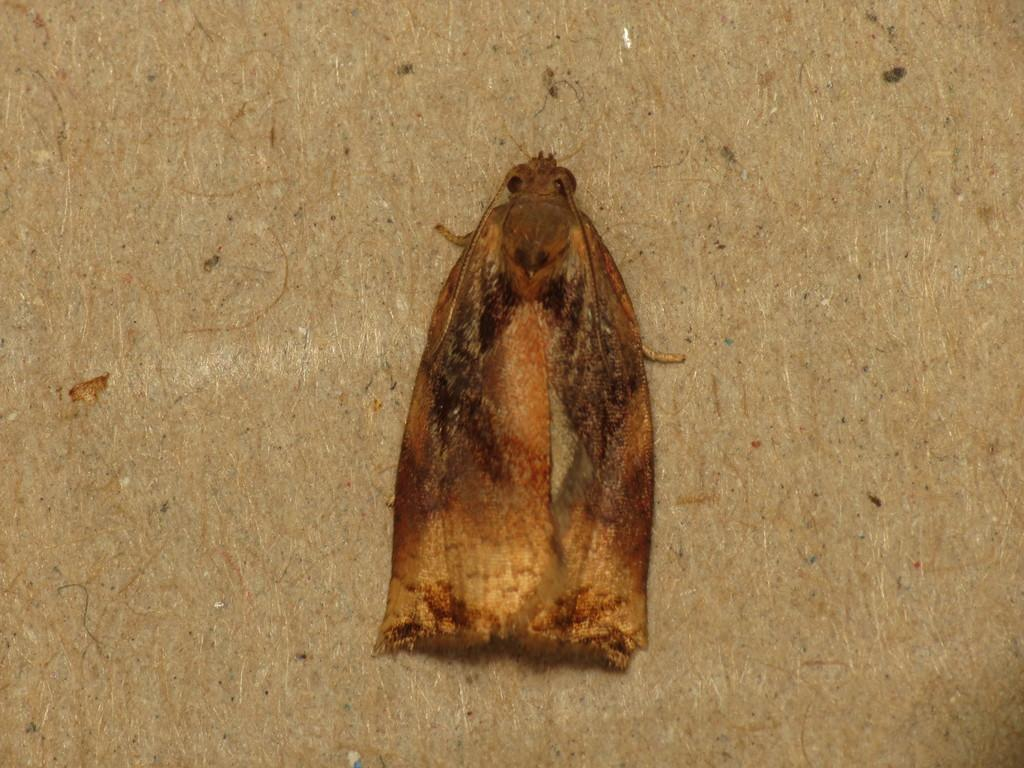What is present in the image? There is an insect in the image. Where is the insect located? The insect is on a wooden platform. How many rings does the insect have on its legs in the image? There are no rings visible on the insect's legs in the image. What type of regret is the insect expressing in the image? There is no indication of regret in the image, as insects do not have the ability to express emotions like regret. 